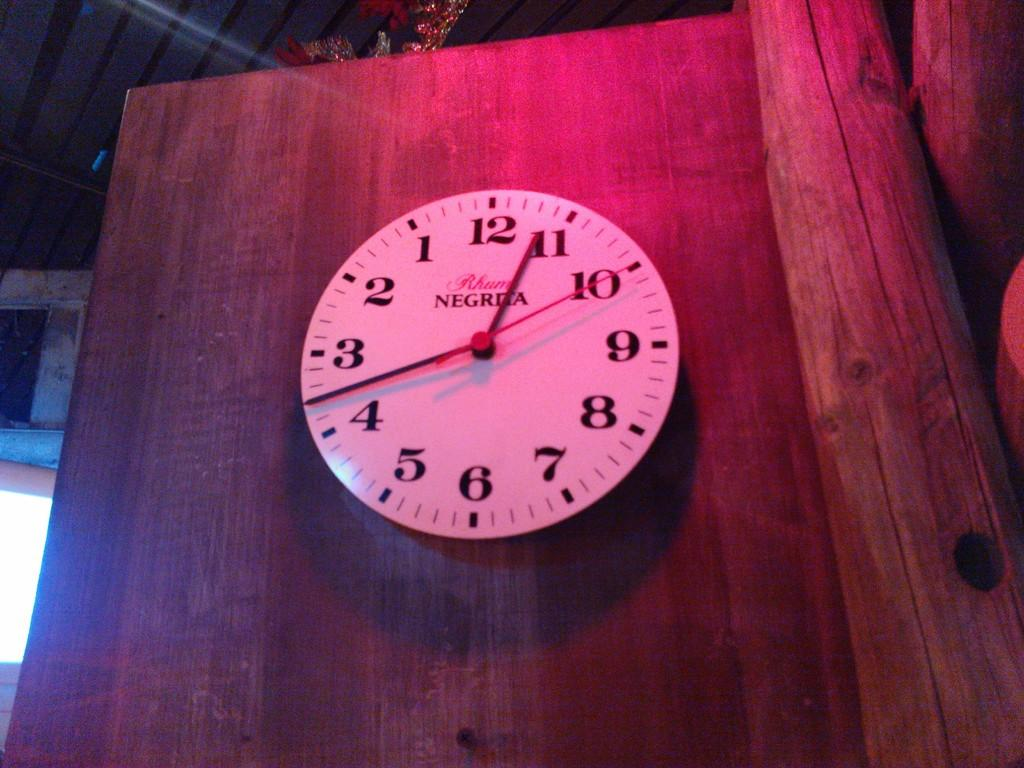Provide a one-sentence caption for the provided image. A clock on a wooden door was made by Negrita. 